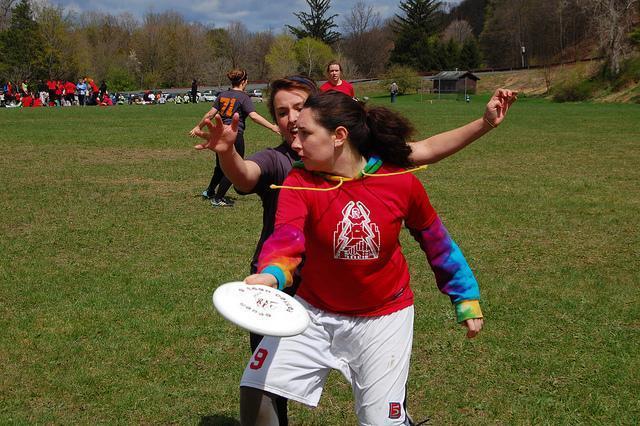How many people are there?
Give a very brief answer. 4. 